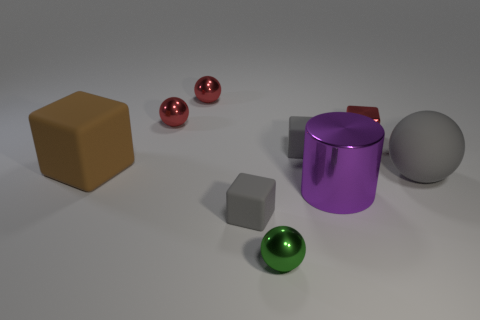Does the cylinder have the same color as the big sphere? The cylinder and the big sphere do not share the same color. The cylinder is a vivid purple, whereas the big sphere is grey. 